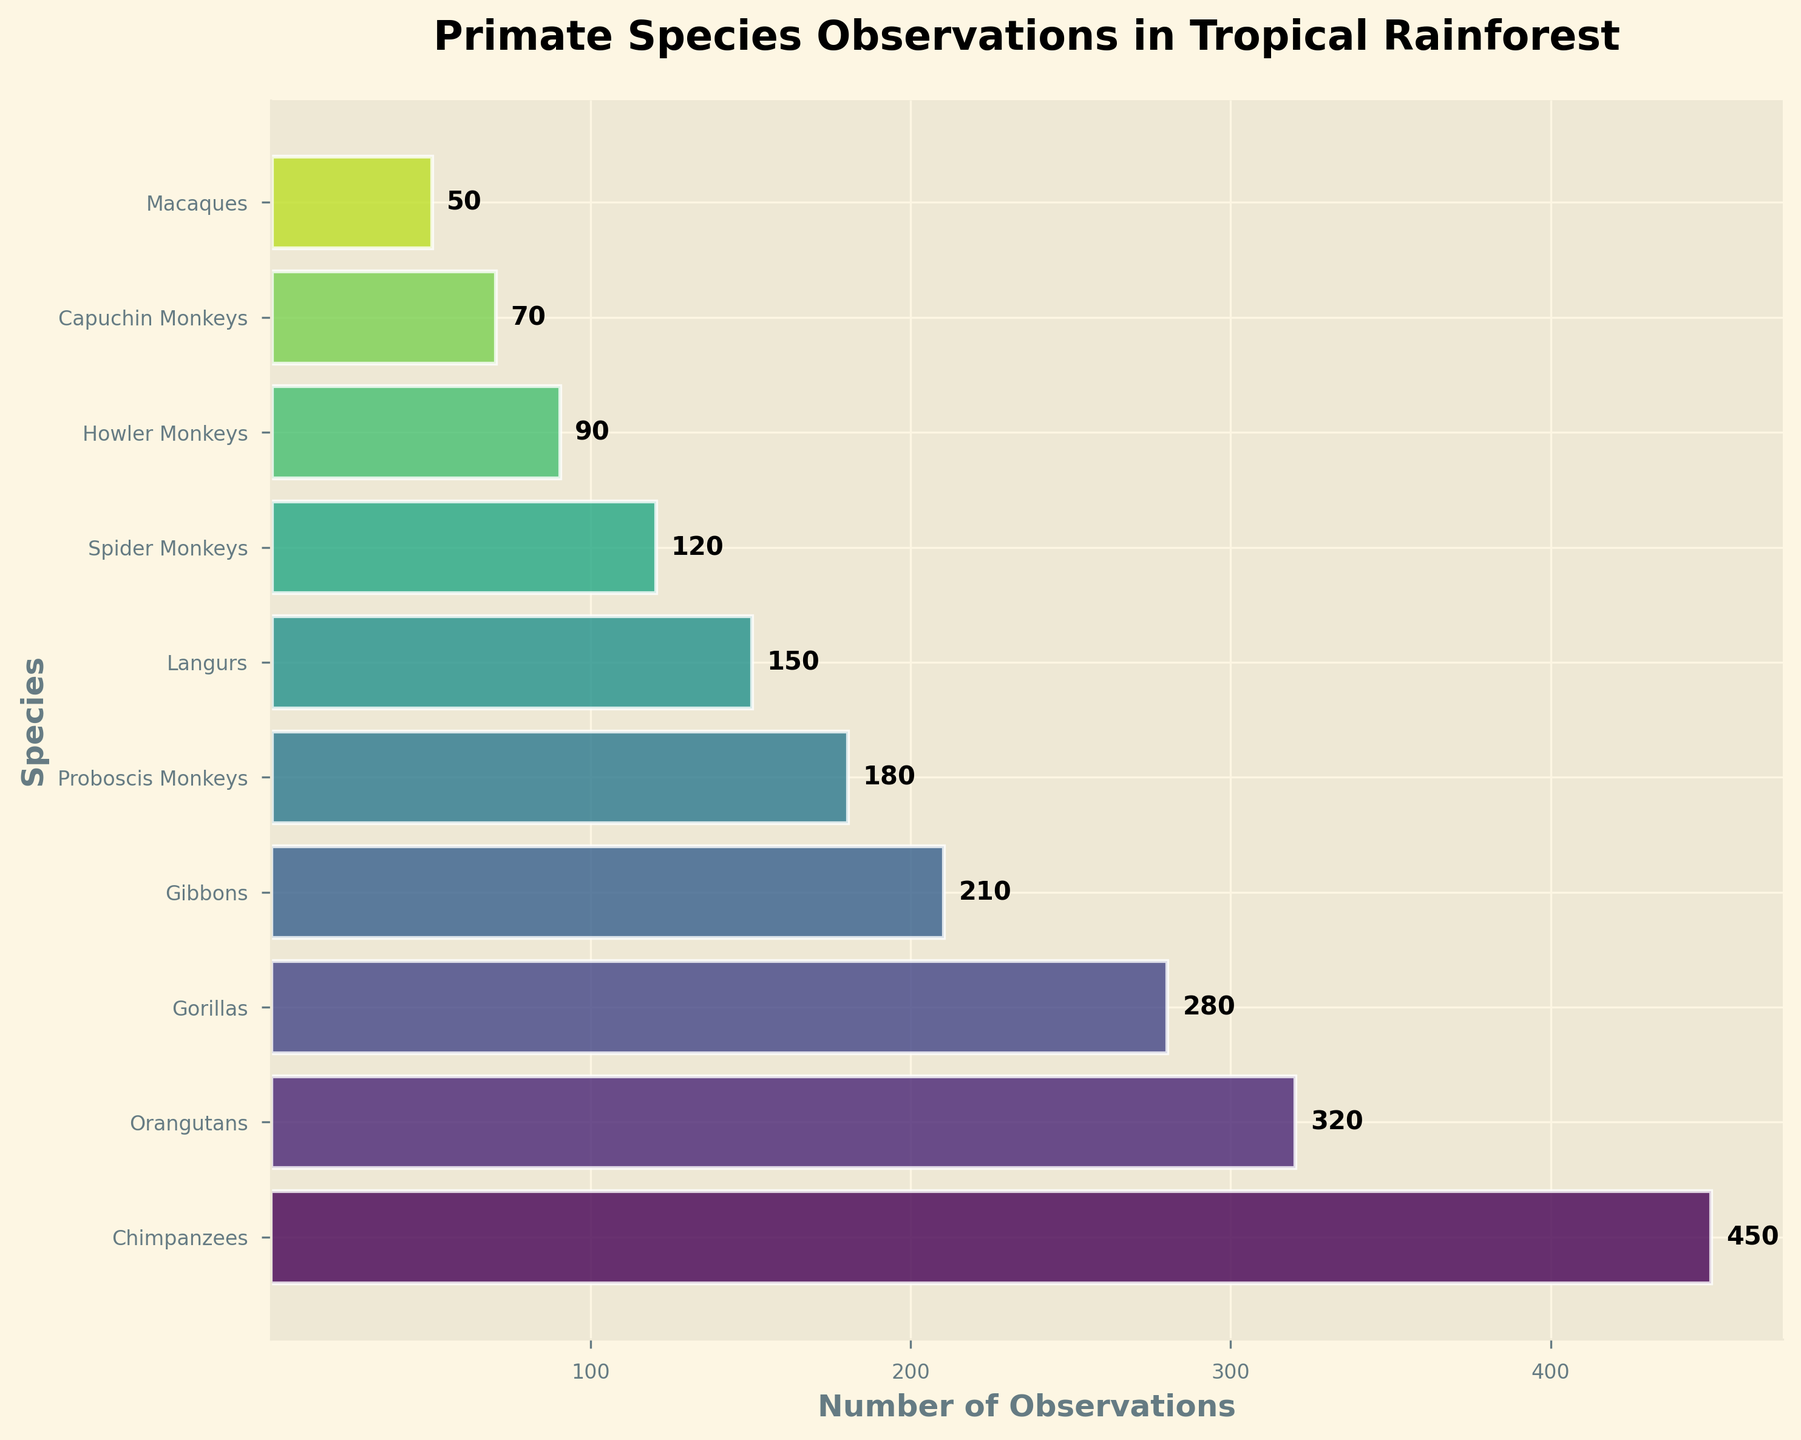What is the title of the chart? The title can be easily seen at the top of the chart.
Answer: Primate Species Observations in Tropical Rainforest Which primate species had the most observations? By looking at the top of the funnel chart, we can identify the species with the highest bar width.
Answer: Chimpanzees How many observations were recorded for Langurs? By locating Langurs on the y-axis and reading the number at the end of its bar, we find this value.
Answer: 150 How many more observations were there for Gibbons compared to Proboscis Monkeys? Find the observations for Gibbons (210) and Proboscis Monkeys (180), then subtract the smaller number from the larger one: 210 - 180.
Answer: 30 What is the total number of observations recorded in the chart? Add up all the observation values: 450 + 320 + 280 + 210 + 180 + 150 + 120 + 90 + 70 + 50.
Answer: 1920 What is the ratio of observations between Chimpanzees and Capuchin Monkeys? Divide the number of observations for Chimpanzees (450) by the number of observations for Capuchin Monkeys (70): 450 / 70.
Answer: 6.43 Which two species showed the closest number of observations? Compare the observation numbers and identify the two species with the smallest difference in their observation counts, which are Gorillas (280) and Gibbons (210) with a difference of 70.
Answer: Gorillas and Gibbons Was there a larger difference in observations between the species with the highest and second-highest observations or the species with the lowest and second-lowest observations? Compare the differences: 
1. Highest vs. second-highest: 450 (Chimpanzees) - 320 (Orangutans) = 130
2. Lowest vs. second-lowest: 70 (Capuchin Monkeys) - 50 (Macaques) = 20
The larger difference is the first one.
Answer: Highest vs. second-highest What is the average number of observations for the species listed? Sum the total number of observations (1920) and divide it by the number of species (10): 1920 / 10.
Answer: 192 How wide is the funnel segment for Gorillas compared to Howler Monkeys? Gorillas have 280 observations, whereas Howler Monkeys have 90. Measure the width relative to the maximum width (80%) and calculate their relative sizes. The Gorillas' segment is wider.
Answer: Wider 